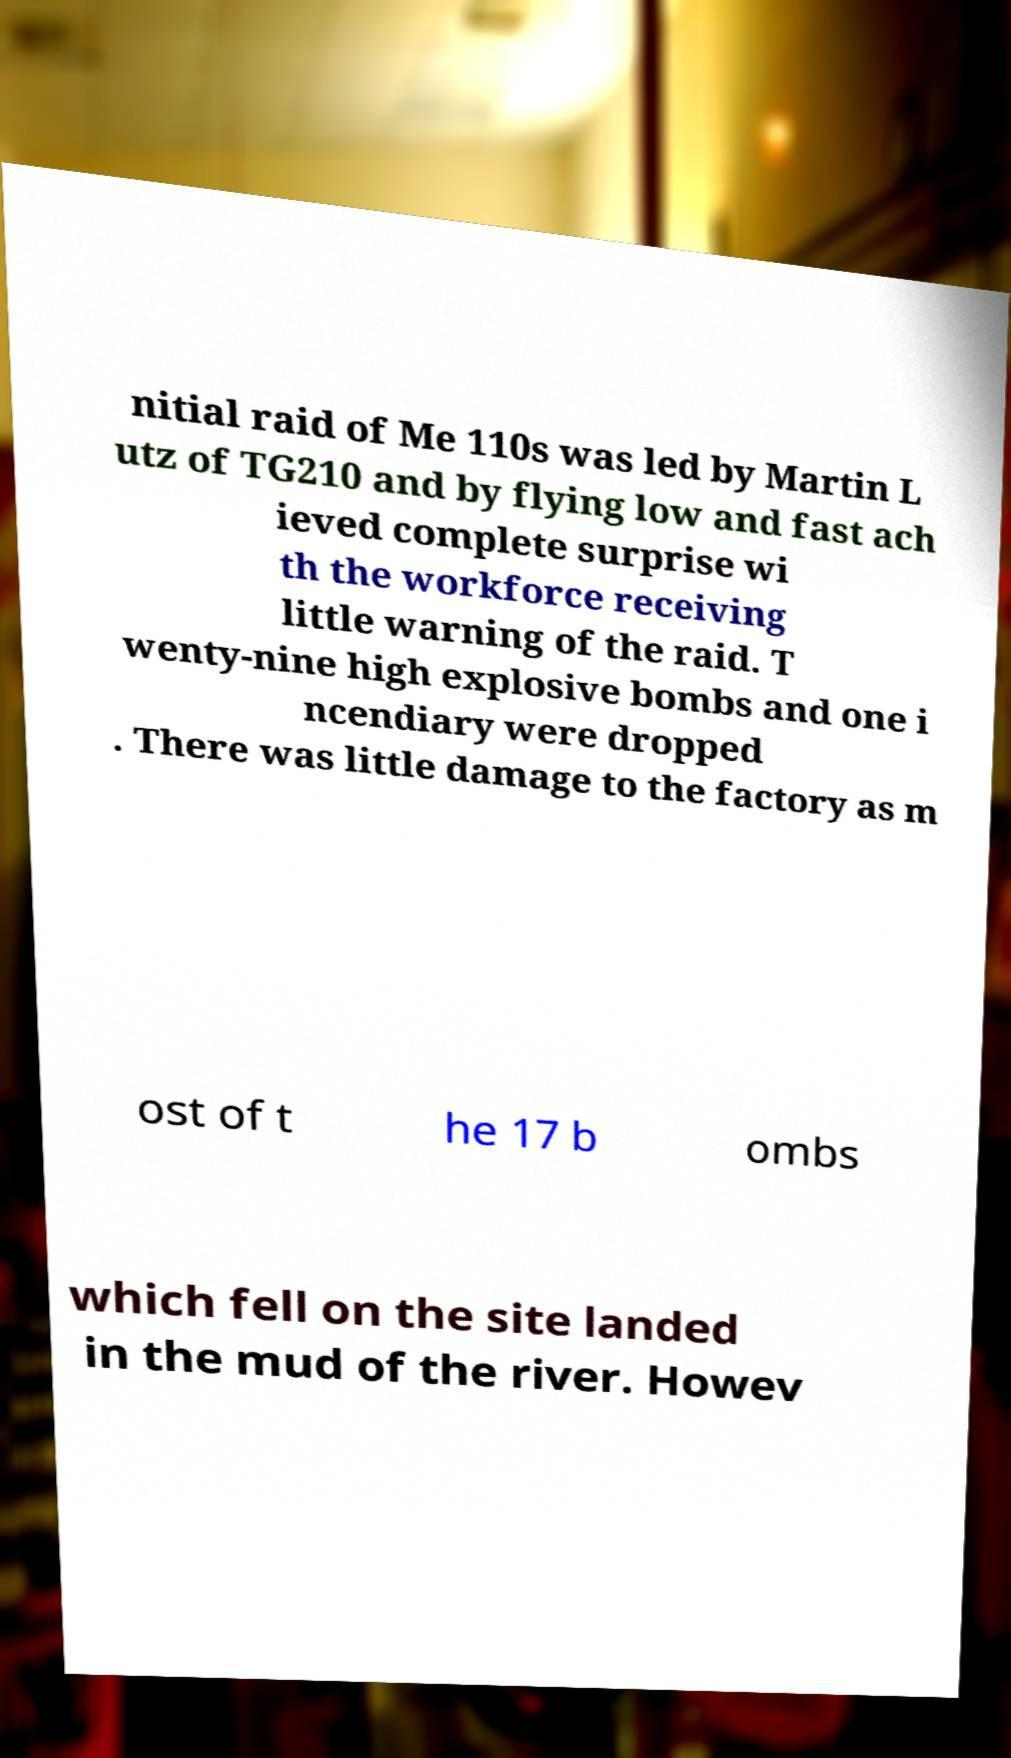What messages or text are displayed in this image? I need them in a readable, typed format. nitial raid of Me 110s was led by Martin L utz of TG210 and by flying low and fast ach ieved complete surprise wi th the workforce receiving little warning of the raid. T wenty-nine high explosive bombs and one i ncendiary were dropped . There was little damage to the factory as m ost of t he 17 b ombs which fell on the site landed in the mud of the river. Howev 